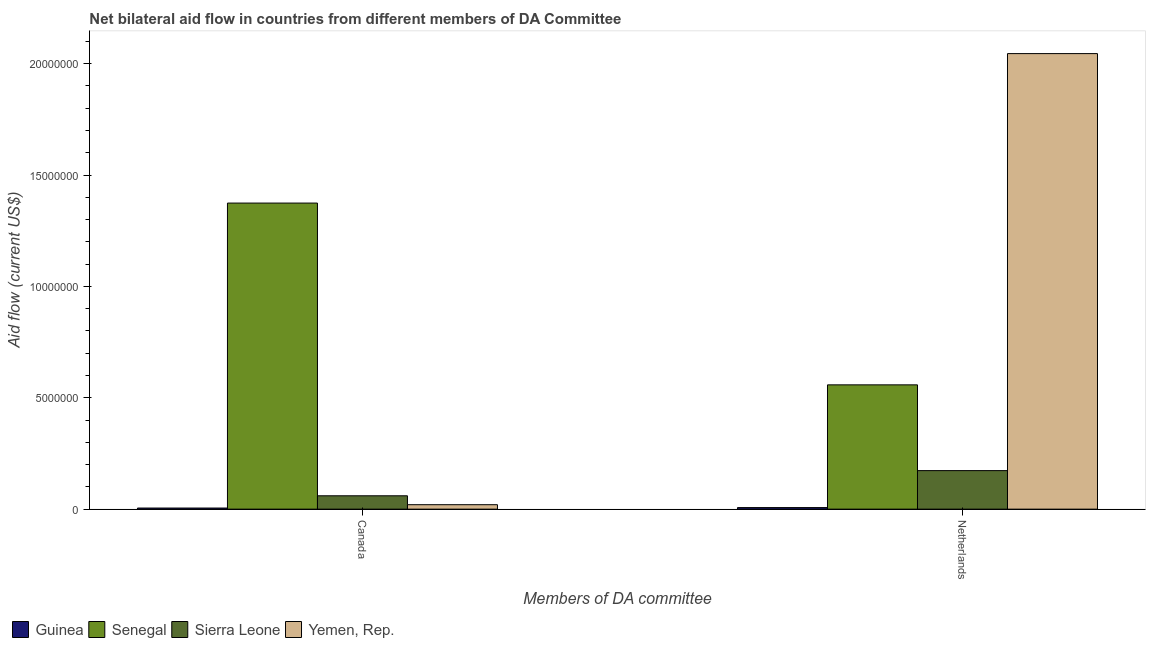How many groups of bars are there?
Provide a succinct answer. 2. How many bars are there on the 2nd tick from the left?
Your answer should be compact. 4. How many bars are there on the 1st tick from the right?
Your answer should be very brief. 4. What is the amount of aid given by canada in Sierra Leone?
Offer a terse response. 6.00e+05. Across all countries, what is the maximum amount of aid given by canada?
Provide a short and direct response. 1.37e+07. Across all countries, what is the minimum amount of aid given by netherlands?
Provide a short and direct response. 7.00e+04. In which country was the amount of aid given by canada maximum?
Ensure brevity in your answer.  Senegal. In which country was the amount of aid given by netherlands minimum?
Provide a succinct answer. Guinea. What is the total amount of aid given by netherlands in the graph?
Offer a very short reply. 2.78e+07. What is the difference between the amount of aid given by canada in Senegal and that in Sierra Leone?
Your answer should be compact. 1.31e+07. What is the difference between the amount of aid given by canada in Guinea and the amount of aid given by netherlands in Senegal?
Make the answer very short. -5.53e+06. What is the average amount of aid given by canada per country?
Your response must be concise. 3.65e+06. What is the difference between the amount of aid given by canada and amount of aid given by netherlands in Yemen, Rep.?
Your answer should be compact. -2.02e+07. What is the ratio of the amount of aid given by canada in Senegal to that in Guinea?
Keep it short and to the point. 274.8. Is the amount of aid given by netherlands in Yemen, Rep. less than that in Senegal?
Provide a short and direct response. No. In how many countries, is the amount of aid given by netherlands greater than the average amount of aid given by netherlands taken over all countries?
Your response must be concise. 1. What does the 3rd bar from the left in Netherlands represents?
Your answer should be very brief. Sierra Leone. What does the 1st bar from the right in Canada represents?
Offer a terse response. Yemen, Rep. Are all the bars in the graph horizontal?
Your response must be concise. No. How many countries are there in the graph?
Your answer should be compact. 4. Are the values on the major ticks of Y-axis written in scientific E-notation?
Your answer should be very brief. No. Does the graph contain any zero values?
Provide a short and direct response. No. Does the graph contain grids?
Ensure brevity in your answer.  No. How many legend labels are there?
Your response must be concise. 4. How are the legend labels stacked?
Offer a very short reply. Horizontal. What is the title of the graph?
Your answer should be very brief. Net bilateral aid flow in countries from different members of DA Committee. Does "Least developed countries" appear as one of the legend labels in the graph?
Make the answer very short. No. What is the label or title of the X-axis?
Provide a short and direct response. Members of DA committee. What is the Aid flow (current US$) of Guinea in Canada?
Offer a very short reply. 5.00e+04. What is the Aid flow (current US$) of Senegal in Canada?
Provide a short and direct response. 1.37e+07. What is the Aid flow (current US$) in Yemen, Rep. in Canada?
Provide a succinct answer. 2.00e+05. What is the Aid flow (current US$) in Guinea in Netherlands?
Provide a succinct answer. 7.00e+04. What is the Aid flow (current US$) in Senegal in Netherlands?
Offer a very short reply. 5.58e+06. What is the Aid flow (current US$) of Sierra Leone in Netherlands?
Keep it short and to the point. 1.73e+06. What is the Aid flow (current US$) of Yemen, Rep. in Netherlands?
Ensure brevity in your answer.  2.04e+07. Across all Members of DA committee, what is the maximum Aid flow (current US$) of Guinea?
Make the answer very short. 7.00e+04. Across all Members of DA committee, what is the maximum Aid flow (current US$) in Senegal?
Provide a succinct answer. 1.37e+07. Across all Members of DA committee, what is the maximum Aid flow (current US$) in Sierra Leone?
Provide a succinct answer. 1.73e+06. Across all Members of DA committee, what is the maximum Aid flow (current US$) in Yemen, Rep.?
Your answer should be compact. 2.04e+07. Across all Members of DA committee, what is the minimum Aid flow (current US$) in Senegal?
Ensure brevity in your answer.  5.58e+06. Across all Members of DA committee, what is the minimum Aid flow (current US$) of Sierra Leone?
Give a very brief answer. 6.00e+05. What is the total Aid flow (current US$) of Senegal in the graph?
Your answer should be compact. 1.93e+07. What is the total Aid flow (current US$) of Sierra Leone in the graph?
Keep it short and to the point. 2.33e+06. What is the total Aid flow (current US$) in Yemen, Rep. in the graph?
Provide a succinct answer. 2.06e+07. What is the difference between the Aid flow (current US$) of Senegal in Canada and that in Netherlands?
Your answer should be compact. 8.16e+06. What is the difference between the Aid flow (current US$) in Sierra Leone in Canada and that in Netherlands?
Give a very brief answer. -1.13e+06. What is the difference between the Aid flow (current US$) of Yemen, Rep. in Canada and that in Netherlands?
Make the answer very short. -2.02e+07. What is the difference between the Aid flow (current US$) in Guinea in Canada and the Aid flow (current US$) in Senegal in Netherlands?
Provide a succinct answer. -5.53e+06. What is the difference between the Aid flow (current US$) of Guinea in Canada and the Aid flow (current US$) of Sierra Leone in Netherlands?
Ensure brevity in your answer.  -1.68e+06. What is the difference between the Aid flow (current US$) in Guinea in Canada and the Aid flow (current US$) in Yemen, Rep. in Netherlands?
Your answer should be compact. -2.04e+07. What is the difference between the Aid flow (current US$) of Senegal in Canada and the Aid flow (current US$) of Sierra Leone in Netherlands?
Keep it short and to the point. 1.20e+07. What is the difference between the Aid flow (current US$) in Senegal in Canada and the Aid flow (current US$) in Yemen, Rep. in Netherlands?
Provide a succinct answer. -6.71e+06. What is the difference between the Aid flow (current US$) of Sierra Leone in Canada and the Aid flow (current US$) of Yemen, Rep. in Netherlands?
Make the answer very short. -1.98e+07. What is the average Aid flow (current US$) of Guinea per Members of DA committee?
Your answer should be very brief. 6.00e+04. What is the average Aid flow (current US$) of Senegal per Members of DA committee?
Offer a terse response. 9.66e+06. What is the average Aid flow (current US$) in Sierra Leone per Members of DA committee?
Offer a very short reply. 1.16e+06. What is the average Aid flow (current US$) in Yemen, Rep. per Members of DA committee?
Ensure brevity in your answer.  1.03e+07. What is the difference between the Aid flow (current US$) of Guinea and Aid flow (current US$) of Senegal in Canada?
Provide a succinct answer. -1.37e+07. What is the difference between the Aid flow (current US$) of Guinea and Aid flow (current US$) of Sierra Leone in Canada?
Your response must be concise. -5.50e+05. What is the difference between the Aid flow (current US$) of Guinea and Aid flow (current US$) of Yemen, Rep. in Canada?
Provide a short and direct response. -1.50e+05. What is the difference between the Aid flow (current US$) of Senegal and Aid flow (current US$) of Sierra Leone in Canada?
Offer a very short reply. 1.31e+07. What is the difference between the Aid flow (current US$) of Senegal and Aid flow (current US$) of Yemen, Rep. in Canada?
Give a very brief answer. 1.35e+07. What is the difference between the Aid flow (current US$) of Guinea and Aid flow (current US$) of Senegal in Netherlands?
Provide a short and direct response. -5.51e+06. What is the difference between the Aid flow (current US$) in Guinea and Aid flow (current US$) in Sierra Leone in Netherlands?
Provide a short and direct response. -1.66e+06. What is the difference between the Aid flow (current US$) in Guinea and Aid flow (current US$) in Yemen, Rep. in Netherlands?
Keep it short and to the point. -2.04e+07. What is the difference between the Aid flow (current US$) of Senegal and Aid flow (current US$) of Sierra Leone in Netherlands?
Your answer should be compact. 3.85e+06. What is the difference between the Aid flow (current US$) of Senegal and Aid flow (current US$) of Yemen, Rep. in Netherlands?
Your answer should be very brief. -1.49e+07. What is the difference between the Aid flow (current US$) in Sierra Leone and Aid flow (current US$) in Yemen, Rep. in Netherlands?
Your response must be concise. -1.87e+07. What is the ratio of the Aid flow (current US$) of Guinea in Canada to that in Netherlands?
Offer a very short reply. 0.71. What is the ratio of the Aid flow (current US$) of Senegal in Canada to that in Netherlands?
Provide a succinct answer. 2.46. What is the ratio of the Aid flow (current US$) in Sierra Leone in Canada to that in Netherlands?
Your answer should be very brief. 0.35. What is the ratio of the Aid flow (current US$) in Yemen, Rep. in Canada to that in Netherlands?
Provide a short and direct response. 0.01. What is the difference between the highest and the second highest Aid flow (current US$) of Senegal?
Make the answer very short. 8.16e+06. What is the difference between the highest and the second highest Aid flow (current US$) of Sierra Leone?
Offer a terse response. 1.13e+06. What is the difference between the highest and the second highest Aid flow (current US$) in Yemen, Rep.?
Give a very brief answer. 2.02e+07. What is the difference between the highest and the lowest Aid flow (current US$) of Senegal?
Provide a short and direct response. 8.16e+06. What is the difference between the highest and the lowest Aid flow (current US$) in Sierra Leone?
Provide a short and direct response. 1.13e+06. What is the difference between the highest and the lowest Aid flow (current US$) in Yemen, Rep.?
Offer a very short reply. 2.02e+07. 